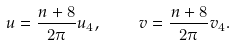<formula> <loc_0><loc_0><loc_500><loc_500>u = { \frac { n + 8 } { 2 \pi } } u _ { 4 } , \quad v = { \frac { n + 8 } { 2 \pi } } v _ { 4 } .</formula> 